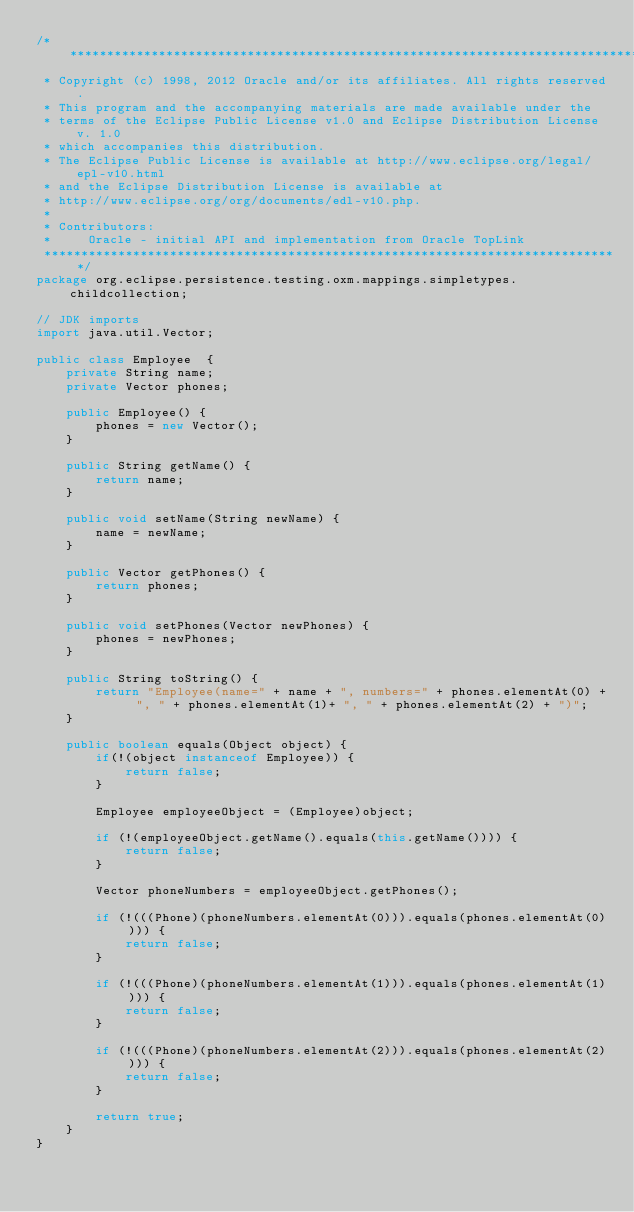Convert code to text. <code><loc_0><loc_0><loc_500><loc_500><_Java_>/*******************************************************************************
 * Copyright (c) 1998, 2012 Oracle and/or its affiliates. All rights reserved.
 * This program and the accompanying materials are made available under the 
 * terms of the Eclipse Public License v1.0 and Eclipse Distribution License v. 1.0 
 * which accompanies this distribution. 
 * The Eclipse Public License is available at http://www.eclipse.org/legal/epl-v10.html
 * and the Eclipse Distribution License is available at 
 * http://www.eclipse.org/org/documents/edl-v10.php.
 *
 * Contributors:
 *     Oracle - initial API and implementation from Oracle TopLink
 ******************************************************************************/  
package org.eclipse.persistence.testing.oxm.mappings.simpletypes.childcollection;

// JDK imports
import java.util.Vector;

public class Employee  {
	private String name;
	private Vector phones;

	public Employee() {
		phones = new Vector();
	}

	public String getName() {
		return name;
	}

	public void setName(String newName) {
		name = newName;
	}

	public Vector getPhones() {
		return phones;
	}
	
	public void setPhones(Vector newPhones) {
		phones = newPhones;
	}
	
	public String toString() {
		return "Employee(name=" + name + ", numbers=" + phones.elementAt(0) + ", " + phones.elementAt(1)+ ", " + phones.elementAt(2) + ")";
	}

	public boolean equals(Object object) {
		if(!(object instanceof Employee)) {
			return false;
		}
	
		Employee employeeObject = (Employee)object;

		if (!(employeeObject.getName().equals(this.getName()))) {
			return false;
		}

		Vector phoneNumbers = employeeObject.getPhones();

		if (!(((Phone)(phoneNumbers.elementAt(0))).equals(phones.elementAt(0)))) {
			return false;
		}

		if (!(((Phone)(phoneNumbers.elementAt(1))).equals(phones.elementAt(1)))) {
			return false;
		}
		
		if (!(((Phone)(phoneNumbers.elementAt(2))).equals(phones.elementAt(2)))) {
			return false;
		}

		return true;
	}
}
</code> 